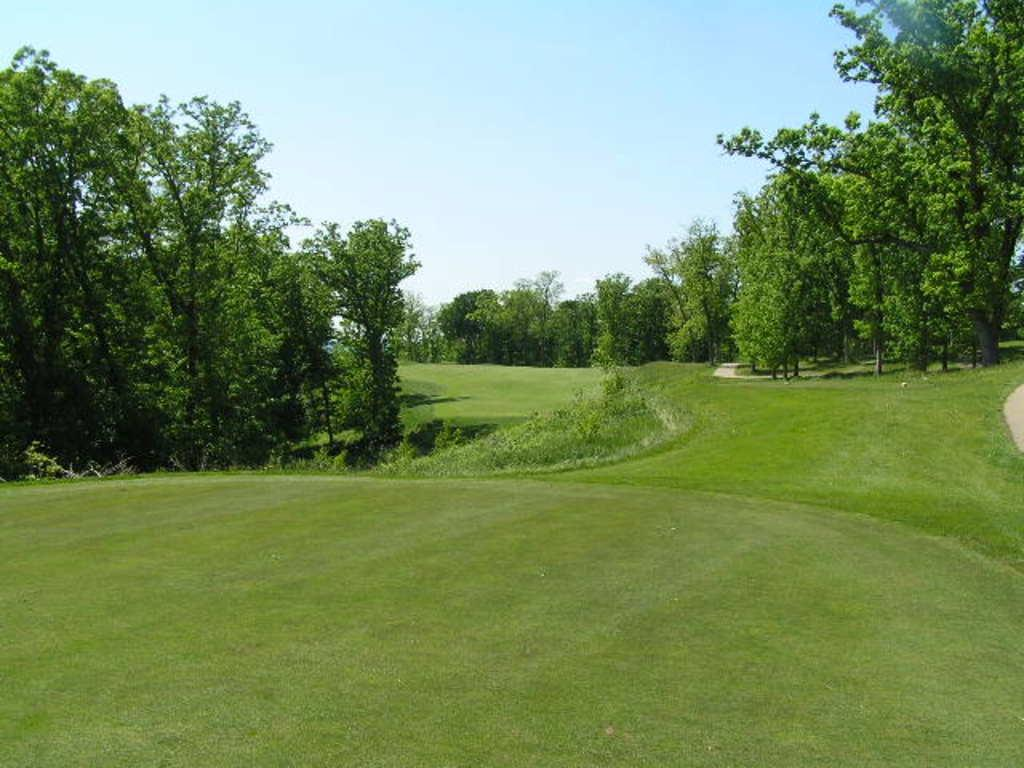What type of surface is on the ground in the image? There is grass on the ground in the image. What can be seen in the background of the image? There are plants and trees in the background of the image. What is visible at the top of the image? The sky is visible at the top of the image. Where is the prison located in the image? There is no prison present in the image. What type of dolls can be seen playing in the image? There are no dolls present in the image. 